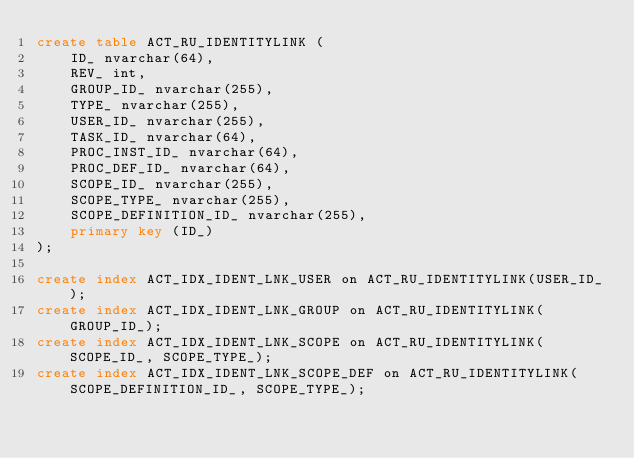<code> <loc_0><loc_0><loc_500><loc_500><_SQL_>create table ACT_RU_IDENTITYLINK (
    ID_ nvarchar(64),
    REV_ int,
    GROUP_ID_ nvarchar(255),
    TYPE_ nvarchar(255),
    USER_ID_ nvarchar(255),
    TASK_ID_ nvarchar(64),
    PROC_INST_ID_ nvarchar(64),
    PROC_DEF_ID_ nvarchar(64),
    SCOPE_ID_ nvarchar(255),
    SCOPE_TYPE_ nvarchar(255),
    SCOPE_DEFINITION_ID_ nvarchar(255),
    primary key (ID_)
);

create index ACT_IDX_IDENT_LNK_USER on ACT_RU_IDENTITYLINK(USER_ID_);
create index ACT_IDX_IDENT_LNK_GROUP on ACT_RU_IDENTITYLINK(GROUP_ID_);
create index ACT_IDX_IDENT_LNK_SCOPE on ACT_RU_IDENTITYLINK(SCOPE_ID_, SCOPE_TYPE_);
create index ACT_IDX_IDENT_LNK_SCOPE_DEF on ACT_RU_IDENTITYLINK(SCOPE_DEFINITION_ID_, SCOPE_TYPE_);
</code> 